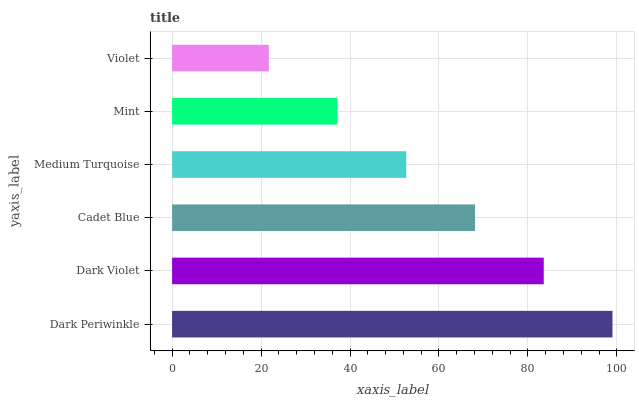Is Violet the minimum?
Answer yes or no. Yes. Is Dark Periwinkle the maximum?
Answer yes or no. Yes. Is Dark Violet the minimum?
Answer yes or no. No. Is Dark Violet the maximum?
Answer yes or no. No. Is Dark Periwinkle greater than Dark Violet?
Answer yes or no. Yes. Is Dark Violet less than Dark Periwinkle?
Answer yes or no. Yes. Is Dark Violet greater than Dark Periwinkle?
Answer yes or no. No. Is Dark Periwinkle less than Dark Violet?
Answer yes or no. No. Is Cadet Blue the high median?
Answer yes or no. Yes. Is Medium Turquoise the low median?
Answer yes or no. Yes. Is Mint the high median?
Answer yes or no. No. Is Dark Violet the low median?
Answer yes or no. No. 